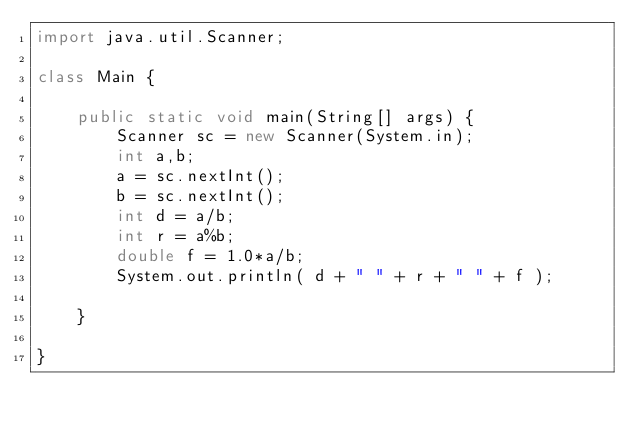Convert code to text. <code><loc_0><loc_0><loc_500><loc_500><_Java_>import java.util.Scanner;

class Main {

	public static void main(String[] args) {
		Scanner sc = new Scanner(System.in);
		int a,b;
		a = sc.nextInt();
		b = sc.nextInt();
		int d = a/b;
		int r = a%b;
		double f = 1.0*a/b;		
		System.out.println( d + " " + r + " " + f );

	}

}</code> 